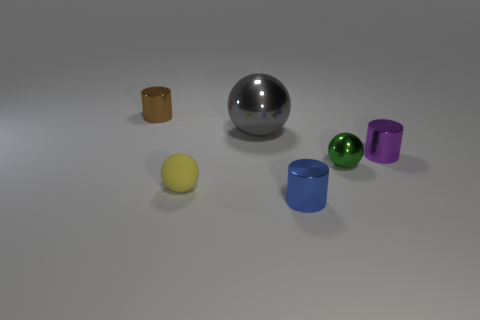Are there any other things that have the same size as the gray thing?
Keep it short and to the point. No. How many big metallic spheres have the same color as the big metallic object?
Your response must be concise. 0. How many things are either objects that are behind the blue cylinder or small objects in front of the brown cylinder?
Offer a very short reply. 6. What number of small purple metal cylinders are on the left side of the small metallic thing on the left side of the gray ball?
Your response must be concise. 0. There is a big ball that is made of the same material as the small purple cylinder; what is its color?
Offer a very short reply. Gray. Are there any matte things that have the same size as the purple shiny cylinder?
Your response must be concise. Yes. What is the shape of the green thing that is the same size as the brown metallic thing?
Your response must be concise. Sphere. Is there a large object that has the same shape as the small green object?
Offer a very short reply. Yes. Is the tiny green sphere made of the same material as the small cylinder to the right of the tiny green ball?
Your response must be concise. Yes. What number of other objects are the same material as the tiny brown thing?
Offer a very short reply. 4. 